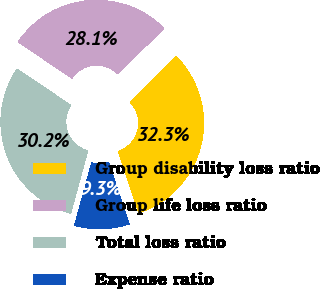Convert chart to OTSL. <chart><loc_0><loc_0><loc_500><loc_500><pie_chart><fcel>Group disability loss ratio<fcel>Group life loss ratio<fcel>Total loss ratio<fcel>Expense ratio<nl><fcel>32.32%<fcel>28.13%<fcel>30.22%<fcel>9.33%<nl></chart> 